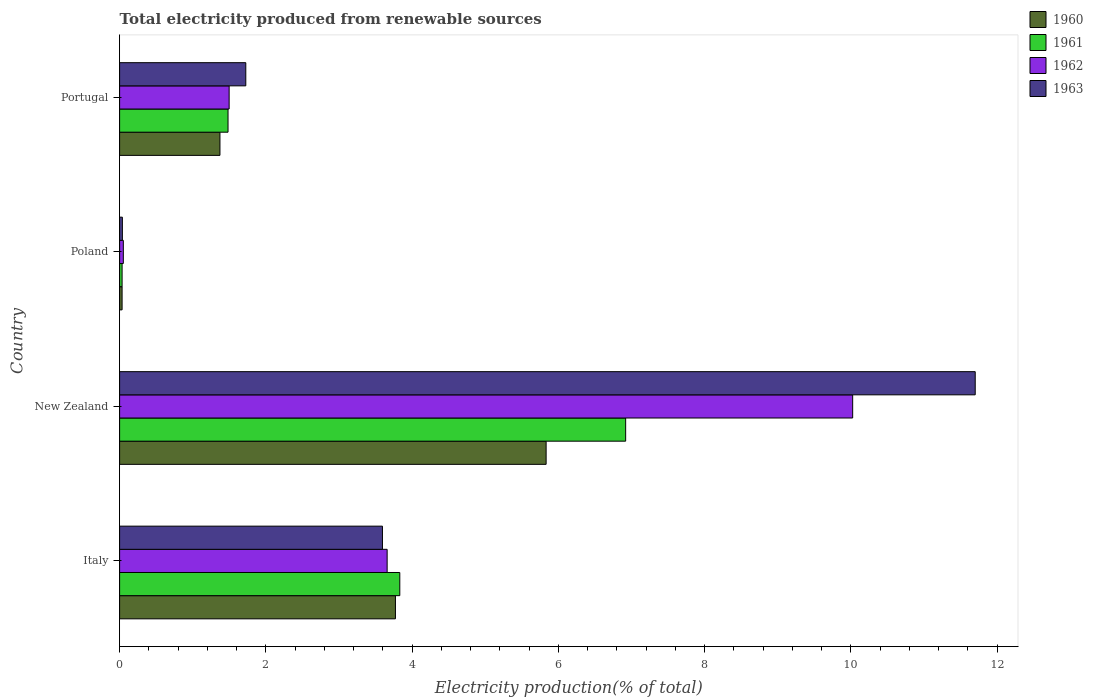How many different coloured bars are there?
Your answer should be compact. 4. Are the number of bars per tick equal to the number of legend labels?
Offer a terse response. Yes. How many bars are there on the 4th tick from the bottom?
Make the answer very short. 4. What is the label of the 3rd group of bars from the top?
Your answer should be compact. New Zealand. In how many cases, is the number of bars for a given country not equal to the number of legend labels?
Your answer should be very brief. 0. What is the total electricity produced in 1962 in Poland?
Provide a succinct answer. 0.05. Across all countries, what is the maximum total electricity produced in 1960?
Your answer should be compact. 5.83. Across all countries, what is the minimum total electricity produced in 1962?
Your response must be concise. 0.05. In which country was the total electricity produced in 1963 maximum?
Offer a terse response. New Zealand. In which country was the total electricity produced in 1963 minimum?
Keep it short and to the point. Poland. What is the total total electricity produced in 1961 in the graph?
Offer a very short reply. 12.27. What is the difference between the total electricity produced in 1960 in New Zealand and that in Portugal?
Offer a very short reply. 4.46. What is the difference between the total electricity produced in 1963 in Poland and the total electricity produced in 1960 in Portugal?
Ensure brevity in your answer.  -1.33. What is the average total electricity produced in 1960 per country?
Provide a succinct answer. 2.75. What is the difference between the total electricity produced in 1961 and total electricity produced in 1960 in Poland?
Keep it short and to the point. -3.156606850160393e-5. In how many countries, is the total electricity produced in 1963 greater than 2 %?
Provide a short and direct response. 2. What is the ratio of the total electricity produced in 1963 in Italy to that in Poland?
Provide a short and direct response. 94.84. What is the difference between the highest and the second highest total electricity produced in 1960?
Offer a terse response. 2.06. What is the difference between the highest and the lowest total electricity produced in 1961?
Your response must be concise. 6.89. In how many countries, is the total electricity produced in 1963 greater than the average total electricity produced in 1963 taken over all countries?
Provide a succinct answer. 1. Is it the case that in every country, the sum of the total electricity produced in 1961 and total electricity produced in 1963 is greater than the sum of total electricity produced in 1960 and total electricity produced in 1962?
Your response must be concise. No. What does the 4th bar from the top in Portugal represents?
Provide a succinct answer. 1960. What does the 2nd bar from the bottom in New Zealand represents?
Give a very brief answer. 1961. How many bars are there?
Offer a terse response. 16. How many countries are there in the graph?
Provide a succinct answer. 4. Where does the legend appear in the graph?
Ensure brevity in your answer.  Top right. How are the legend labels stacked?
Keep it short and to the point. Vertical. What is the title of the graph?
Offer a very short reply. Total electricity produced from renewable sources. Does "1978" appear as one of the legend labels in the graph?
Your response must be concise. No. What is the label or title of the X-axis?
Your answer should be compact. Electricity production(% of total). What is the label or title of the Y-axis?
Make the answer very short. Country. What is the Electricity production(% of total) in 1960 in Italy?
Ensure brevity in your answer.  3.77. What is the Electricity production(% of total) in 1961 in Italy?
Give a very brief answer. 3.83. What is the Electricity production(% of total) in 1962 in Italy?
Provide a succinct answer. 3.66. What is the Electricity production(% of total) in 1963 in Italy?
Give a very brief answer. 3.59. What is the Electricity production(% of total) of 1960 in New Zealand?
Keep it short and to the point. 5.83. What is the Electricity production(% of total) in 1961 in New Zealand?
Provide a succinct answer. 6.92. What is the Electricity production(% of total) in 1962 in New Zealand?
Offer a very short reply. 10.02. What is the Electricity production(% of total) in 1963 in New Zealand?
Keep it short and to the point. 11.7. What is the Electricity production(% of total) of 1960 in Poland?
Provide a short and direct response. 0.03. What is the Electricity production(% of total) in 1961 in Poland?
Offer a terse response. 0.03. What is the Electricity production(% of total) of 1962 in Poland?
Keep it short and to the point. 0.05. What is the Electricity production(% of total) of 1963 in Poland?
Your response must be concise. 0.04. What is the Electricity production(% of total) of 1960 in Portugal?
Offer a terse response. 1.37. What is the Electricity production(% of total) in 1961 in Portugal?
Keep it short and to the point. 1.48. What is the Electricity production(% of total) in 1962 in Portugal?
Give a very brief answer. 1.5. What is the Electricity production(% of total) of 1963 in Portugal?
Your answer should be compact. 1.73. Across all countries, what is the maximum Electricity production(% of total) in 1960?
Keep it short and to the point. 5.83. Across all countries, what is the maximum Electricity production(% of total) of 1961?
Keep it short and to the point. 6.92. Across all countries, what is the maximum Electricity production(% of total) in 1962?
Your answer should be compact. 10.02. Across all countries, what is the maximum Electricity production(% of total) of 1963?
Keep it short and to the point. 11.7. Across all countries, what is the minimum Electricity production(% of total) in 1960?
Give a very brief answer. 0.03. Across all countries, what is the minimum Electricity production(% of total) in 1961?
Offer a very short reply. 0.03. Across all countries, what is the minimum Electricity production(% of total) of 1962?
Your answer should be compact. 0.05. Across all countries, what is the minimum Electricity production(% of total) of 1963?
Your response must be concise. 0.04. What is the total Electricity production(% of total) in 1960 in the graph?
Offer a very short reply. 11.01. What is the total Electricity production(% of total) of 1961 in the graph?
Give a very brief answer. 12.27. What is the total Electricity production(% of total) in 1962 in the graph?
Your answer should be very brief. 15.23. What is the total Electricity production(% of total) in 1963 in the graph?
Your response must be concise. 17.06. What is the difference between the Electricity production(% of total) in 1960 in Italy and that in New Zealand?
Make the answer very short. -2.06. What is the difference between the Electricity production(% of total) in 1961 in Italy and that in New Zealand?
Your answer should be very brief. -3.09. What is the difference between the Electricity production(% of total) in 1962 in Italy and that in New Zealand?
Provide a short and direct response. -6.37. What is the difference between the Electricity production(% of total) in 1963 in Italy and that in New Zealand?
Provide a short and direct response. -8.11. What is the difference between the Electricity production(% of total) of 1960 in Italy and that in Poland?
Ensure brevity in your answer.  3.74. What is the difference between the Electricity production(% of total) in 1961 in Italy and that in Poland?
Offer a terse response. 3.8. What is the difference between the Electricity production(% of total) of 1962 in Italy and that in Poland?
Make the answer very short. 3.61. What is the difference between the Electricity production(% of total) in 1963 in Italy and that in Poland?
Offer a very short reply. 3.56. What is the difference between the Electricity production(% of total) of 1960 in Italy and that in Portugal?
Make the answer very short. 2.4. What is the difference between the Electricity production(% of total) in 1961 in Italy and that in Portugal?
Your response must be concise. 2.35. What is the difference between the Electricity production(% of total) of 1962 in Italy and that in Portugal?
Make the answer very short. 2.16. What is the difference between the Electricity production(% of total) in 1963 in Italy and that in Portugal?
Keep it short and to the point. 1.87. What is the difference between the Electricity production(% of total) of 1960 in New Zealand and that in Poland?
Offer a very short reply. 5.8. What is the difference between the Electricity production(% of total) of 1961 in New Zealand and that in Poland?
Offer a very short reply. 6.89. What is the difference between the Electricity production(% of total) of 1962 in New Zealand and that in Poland?
Offer a terse response. 9.97. What is the difference between the Electricity production(% of total) in 1963 in New Zealand and that in Poland?
Ensure brevity in your answer.  11.66. What is the difference between the Electricity production(% of total) of 1960 in New Zealand and that in Portugal?
Your answer should be very brief. 4.46. What is the difference between the Electricity production(% of total) in 1961 in New Zealand and that in Portugal?
Offer a terse response. 5.44. What is the difference between the Electricity production(% of total) in 1962 in New Zealand and that in Portugal?
Offer a very short reply. 8.53. What is the difference between the Electricity production(% of total) of 1963 in New Zealand and that in Portugal?
Give a very brief answer. 9.97. What is the difference between the Electricity production(% of total) of 1960 in Poland and that in Portugal?
Provide a short and direct response. -1.34. What is the difference between the Electricity production(% of total) of 1961 in Poland and that in Portugal?
Ensure brevity in your answer.  -1.45. What is the difference between the Electricity production(% of total) in 1962 in Poland and that in Portugal?
Offer a terse response. -1.45. What is the difference between the Electricity production(% of total) of 1963 in Poland and that in Portugal?
Your answer should be compact. -1.69. What is the difference between the Electricity production(% of total) in 1960 in Italy and the Electricity production(% of total) in 1961 in New Zealand?
Provide a short and direct response. -3.15. What is the difference between the Electricity production(% of total) in 1960 in Italy and the Electricity production(% of total) in 1962 in New Zealand?
Keep it short and to the point. -6.25. What is the difference between the Electricity production(% of total) in 1960 in Italy and the Electricity production(% of total) in 1963 in New Zealand?
Provide a short and direct response. -7.93. What is the difference between the Electricity production(% of total) of 1961 in Italy and the Electricity production(% of total) of 1962 in New Zealand?
Ensure brevity in your answer.  -6.19. What is the difference between the Electricity production(% of total) in 1961 in Italy and the Electricity production(% of total) in 1963 in New Zealand?
Offer a terse response. -7.87. What is the difference between the Electricity production(% of total) in 1962 in Italy and the Electricity production(% of total) in 1963 in New Zealand?
Ensure brevity in your answer.  -8.04. What is the difference between the Electricity production(% of total) in 1960 in Italy and the Electricity production(% of total) in 1961 in Poland?
Your answer should be very brief. 3.74. What is the difference between the Electricity production(% of total) of 1960 in Italy and the Electricity production(% of total) of 1962 in Poland?
Keep it short and to the point. 3.72. What is the difference between the Electricity production(% of total) in 1960 in Italy and the Electricity production(% of total) in 1963 in Poland?
Your answer should be very brief. 3.73. What is the difference between the Electricity production(% of total) of 1961 in Italy and the Electricity production(% of total) of 1962 in Poland?
Offer a terse response. 3.78. What is the difference between the Electricity production(% of total) of 1961 in Italy and the Electricity production(% of total) of 1963 in Poland?
Give a very brief answer. 3.79. What is the difference between the Electricity production(% of total) in 1962 in Italy and the Electricity production(% of total) in 1963 in Poland?
Your answer should be compact. 3.62. What is the difference between the Electricity production(% of total) of 1960 in Italy and the Electricity production(% of total) of 1961 in Portugal?
Your answer should be compact. 2.29. What is the difference between the Electricity production(% of total) of 1960 in Italy and the Electricity production(% of total) of 1962 in Portugal?
Provide a succinct answer. 2.27. What is the difference between the Electricity production(% of total) of 1960 in Italy and the Electricity production(% of total) of 1963 in Portugal?
Your answer should be very brief. 2.05. What is the difference between the Electricity production(% of total) in 1961 in Italy and the Electricity production(% of total) in 1962 in Portugal?
Your answer should be compact. 2.33. What is the difference between the Electricity production(% of total) of 1961 in Italy and the Electricity production(% of total) of 1963 in Portugal?
Offer a terse response. 2.11. What is the difference between the Electricity production(% of total) of 1962 in Italy and the Electricity production(% of total) of 1963 in Portugal?
Your response must be concise. 1.93. What is the difference between the Electricity production(% of total) in 1960 in New Zealand and the Electricity production(% of total) in 1961 in Poland?
Your response must be concise. 5.8. What is the difference between the Electricity production(% of total) of 1960 in New Zealand and the Electricity production(% of total) of 1962 in Poland?
Your answer should be compact. 5.78. What is the difference between the Electricity production(% of total) in 1960 in New Zealand and the Electricity production(% of total) in 1963 in Poland?
Offer a very short reply. 5.79. What is the difference between the Electricity production(% of total) in 1961 in New Zealand and the Electricity production(% of total) in 1962 in Poland?
Provide a short and direct response. 6.87. What is the difference between the Electricity production(% of total) of 1961 in New Zealand and the Electricity production(% of total) of 1963 in Poland?
Make the answer very short. 6.88. What is the difference between the Electricity production(% of total) of 1962 in New Zealand and the Electricity production(% of total) of 1963 in Poland?
Provide a short and direct response. 9.99. What is the difference between the Electricity production(% of total) in 1960 in New Zealand and the Electricity production(% of total) in 1961 in Portugal?
Offer a terse response. 4.35. What is the difference between the Electricity production(% of total) of 1960 in New Zealand and the Electricity production(% of total) of 1962 in Portugal?
Provide a short and direct response. 4.33. What is the difference between the Electricity production(% of total) of 1960 in New Zealand and the Electricity production(% of total) of 1963 in Portugal?
Provide a short and direct response. 4.11. What is the difference between the Electricity production(% of total) in 1961 in New Zealand and the Electricity production(% of total) in 1962 in Portugal?
Keep it short and to the point. 5.42. What is the difference between the Electricity production(% of total) in 1961 in New Zealand and the Electricity production(% of total) in 1963 in Portugal?
Offer a very short reply. 5.19. What is the difference between the Electricity production(% of total) of 1962 in New Zealand and the Electricity production(% of total) of 1963 in Portugal?
Your response must be concise. 8.3. What is the difference between the Electricity production(% of total) in 1960 in Poland and the Electricity production(% of total) in 1961 in Portugal?
Provide a succinct answer. -1.45. What is the difference between the Electricity production(% of total) in 1960 in Poland and the Electricity production(% of total) in 1962 in Portugal?
Ensure brevity in your answer.  -1.46. What is the difference between the Electricity production(% of total) in 1960 in Poland and the Electricity production(% of total) in 1963 in Portugal?
Provide a short and direct response. -1.69. What is the difference between the Electricity production(% of total) of 1961 in Poland and the Electricity production(% of total) of 1962 in Portugal?
Keep it short and to the point. -1.46. What is the difference between the Electricity production(% of total) in 1961 in Poland and the Electricity production(% of total) in 1963 in Portugal?
Give a very brief answer. -1.69. What is the difference between the Electricity production(% of total) in 1962 in Poland and the Electricity production(% of total) in 1963 in Portugal?
Your answer should be compact. -1.67. What is the average Electricity production(% of total) in 1960 per country?
Offer a very short reply. 2.75. What is the average Electricity production(% of total) of 1961 per country?
Make the answer very short. 3.07. What is the average Electricity production(% of total) of 1962 per country?
Your answer should be compact. 3.81. What is the average Electricity production(% of total) of 1963 per country?
Offer a very short reply. 4.26. What is the difference between the Electricity production(% of total) of 1960 and Electricity production(% of total) of 1961 in Italy?
Make the answer very short. -0.06. What is the difference between the Electricity production(% of total) in 1960 and Electricity production(% of total) in 1962 in Italy?
Offer a very short reply. 0.11. What is the difference between the Electricity production(% of total) in 1960 and Electricity production(% of total) in 1963 in Italy?
Offer a terse response. 0.18. What is the difference between the Electricity production(% of total) in 1961 and Electricity production(% of total) in 1962 in Italy?
Your answer should be very brief. 0.17. What is the difference between the Electricity production(% of total) of 1961 and Electricity production(% of total) of 1963 in Italy?
Ensure brevity in your answer.  0.24. What is the difference between the Electricity production(% of total) in 1962 and Electricity production(% of total) in 1963 in Italy?
Offer a very short reply. 0.06. What is the difference between the Electricity production(% of total) of 1960 and Electricity production(% of total) of 1961 in New Zealand?
Offer a terse response. -1.09. What is the difference between the Electricity production(% of total) of 1960 and Electricity production(% of total) of 1962 in New Zealand?
Make the answer very short. -4.19. What is the difference between the Electricity production(% of total) in 1960 and Electricity production(% of total) in 1963 in New Zealand?
Offer a very short reply. -5.87. What is the difference between the Electricity production(% of total) of 1961 and Electricity production(% of total) of 1962 in New Zealand?
Provide a short and direct response. -3.1. What is the difference between the Electricity production(% of total) in 1961 and Electricity production(% of total) in 1963 in New Zealand?
Your response must be concise. -4.78. What is the difference between the Electricity production(% of total) in 1962 and Electricity production(% of total) in 1963 in New Zealand?
Your answer should be compact. -1.68. What is the difference between the Electricity production(% of total) in 1960 and Electricity production(% of total) in 1962 in Poland?
Offer a very short reply. -0.02. What is the difference between the Electricity production(% of total) in 1960 and Electricity production(% of total) in 1963 in Poland?
Your answer should be very brief. -0. What is the difference between the Electricity production(% of total) in 1961 and Electricity production(% of total) in 1962 in Poland?
Your answer should be compact. -0.02. What is the difference between the Electricity production(% of total) in 1961 and Electricity production(% of total) in 1963 in Poland?
Your answer should be compact. -0. What is the difference between the Electricity production(% of total) of 1962 and Electricity production(% of total) of 1963 in Poland?
Provide a succinct answer. 0.01. What is the difference between the Electricity production(% of total) in 1960 and Electricity production(% of total) in 1961 in Portugal?
Make the answer very short. -0.11. What is the difference between the Electricity production(% of total) in 1960 and Electricity production(% of total) in 1962 in Portugal?
Ensure brevity in your answer.  -0.13. What is the difference between the Electricity production(% of total) of 1960 and Electricity production(% of total) of 1963 in Portugal?
Provide a short and direct response. -0.35. What is the difference between the Electricity production(% of total) in 1961 and Electricity production(% of total) in 1962 in Portugal?
Offer a very short reply. -0.02. What is the difference between the Electricity production(% of total) in 1961 and Electricity production(% of total) in 1963 in Portugal?
Make the answer very short. -0.24. What is the difference between the Electricity production(% of total) of 1962 and Electricity production(% of total) of 1963 in Portugal?
Offer a terse response. -0.23. What is the ratio of the Electricity production(% of total) of 1960 in Italy to that in New Zealand?
Offer a terse response. 0.65. What is the ratio of the Electricity production(% of total) of 1961 in Italy to that in New Zealand?
Your answer should be very brief. 0.55. What is the ratio of the Electricity production(% of total) of 1962 in Italy to that in New Zealand?
Keep it short and to the point. 0.36. What is the ratio of the Electricity production(% of total) in 1963 in Italy to that in New Zealand?
Offer a terse response. 0.31. What is the ratio of the Electricity production(% of total) of 1960 in Italy to that in Poland?
Provide a short and direct response. 110.45. What is the ratio of the Electricity production(% of total) of 1961 in Italy to that in Poland?
Offer a very short reply. 112.3. What is the ratio of the Electricity production(% of total) in 1962 in Italy to that in Poland?
Provide a short and direct response. 71.88. What is the ratio of the Electricity production(% of total) in 1963 in Italy to that in Poland?
Provide a short and direct response. 94.84. What is the ratio of the Electricity production(% of total) in 1960 in Italy to that in Portugal?
Your answer should be very brief. 2.75. What is the ratio of the Electricity production(% of total) in 1961 in Italy to that in Portugal?
Ensure brevity in your answer.  2.58. What is the ratio of the Electricity production(% of total) in 1962 in Italy to that in Portugal?
Provide a short and direct response. 2.44. What is the ratio of the Electricity production(% of total) in 1963 in Italy to that in Portugal?
Make the answer very short. 2.08. What is the ratio of the Electricity production(% of total) in 1960 in New Zealand to that in Poland?
Provide a succinct answer. 170.79. What is the ratio of the Electricity production(% of total) in 1961 in New Zealand to that in Poland?
Your answer should be compact. 202.83. What is the ratio of the Electricity production(% of total) in 1962 in New Zealand to that in Poland?
Ensure brevity in your answer.  196.95. What is the ratio of the Electricity production(% of total) in 1963 in New Zealand to that in Poland?
Offer a terse response. 308.73. What is the ratio of the Electricity production(% of total) of 1960 in New Zealand to that in Portugal?
Offer a very short reply. 4.25. What is the ratio of the Electricity production(% of total) of 1961 in New Zealand to that in Portugal?
Provide a succinct answer. 4.67. What is the ratio of the Electricity production(% of total) of 1962 in New Zealand to that in Portugal?
Offer a terse response. 6.69. What is the ratio of the Electricity production(% of total) in 1963 in New Zealand to that in Portugal?
Your answer should be compact. 6.78. What is the ratio of the Electricity production(% of total) in 1960 in Poland to that in Portugal?
Provide a succinct answer. 0.02. What is the ratio of the Electricity production(% of total) of 1961 in Poland to that in Portugal?
Provide a succinct answer. 0.02. What is the ratio of the Electricity production(% of total) of 1962 in Poland to that in Portugal?
Offer a very short reply. 0.03. What is the ratio of the Electricity production(% of total) of 1963 in Poland to that in Portugal?
Provide a succinct answer. 0.02. What is the difference between the highest and the second highest Electricity production(% of total) in 1960?
Make the answer very short. 2.06. What is the difference between the highest and the second highest Electricity production(% of total) of 1961?
Offer a very short reply. 3.09. What is the difference between the highest and the second highest Electricity production(% of total) in 1962?
Your answer should be compact. 6.37. What is the difference between the highest and the second highest Electricity production(% of total) in 1963?
Provide a succinct answer. 8.11. What is the difference between the highest and the lowest Electricity production(% of total) in 1960?
Your response must be concise. 5.8. What is the difference between the highest and the lowest Electricity production(% of total) of 1961?
Keep it short and to the point. 6.89. What is the difference between the highest and the lowest Electricity production(% of total) of 1962?
Keep it short and to the point. 9.97. What is the difference between the highest and the lowest Electricity production(% of total) in 1963?
Provide a succinct answer. 11.66. 